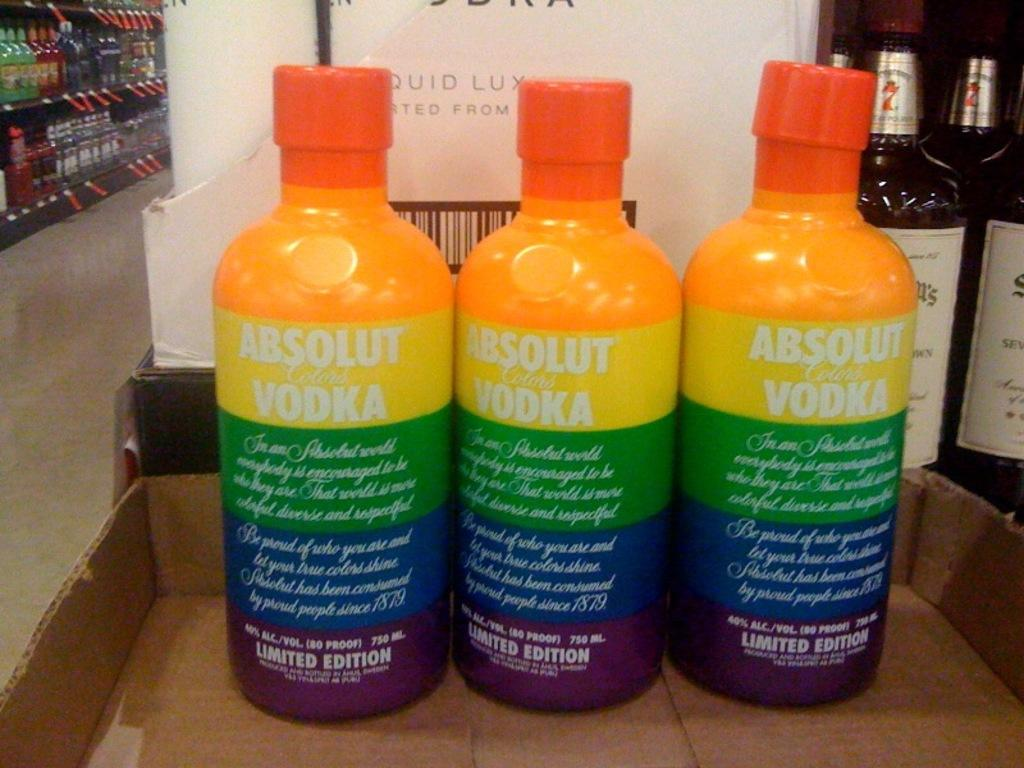<image>
Render a clear and concise summary of the photo. three rainbow colored bottles of Absolut colors Vodka 